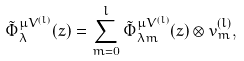<formula> <loc_0><loc_0><loc_500><loc_500>\tilde { \Phi } _ { \lambda } ^ { \mu V ^ { ( l ) } } ( z ) = \sum _ { m = 0 } ^ { l } \tilde { \Phi } _ { \lambda m } ^ { \mu V ^ { ( l ) } } ( z ) \otimes v ^ { ( l ) } _ { m } ,</formula> 